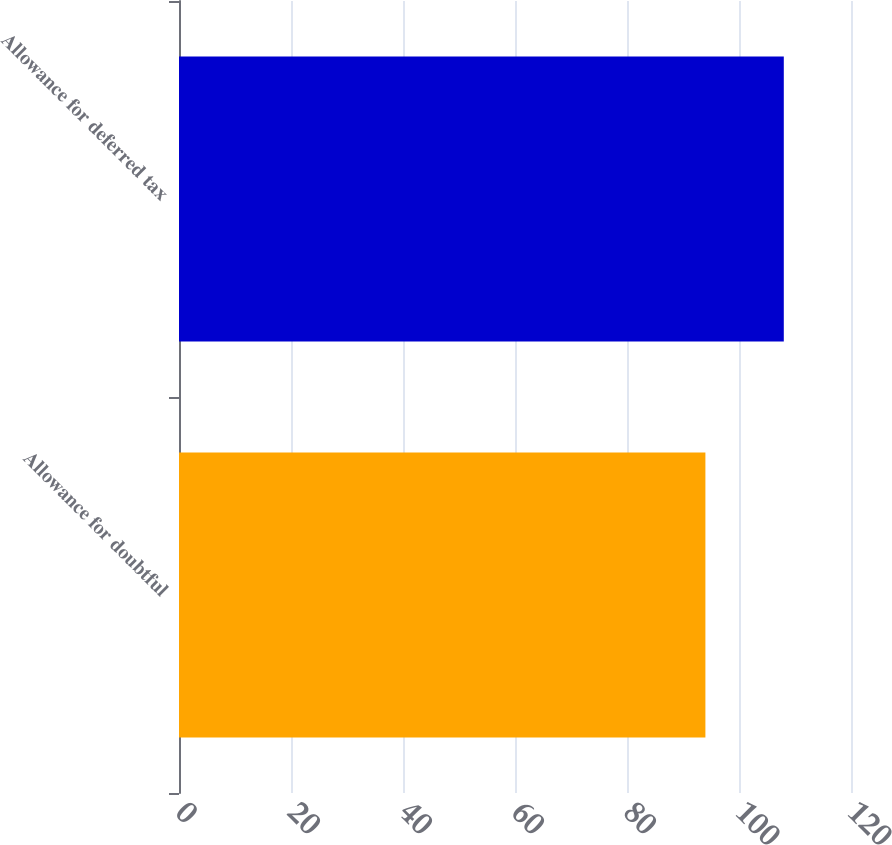<chart> <loc_0><loc_0><loc_500><loc_500><bar_chart><fcel>Allowance for doubtful<fcel>Allowance for deferred tax<nl><fcel>94<fcel>108<nl></chart> 